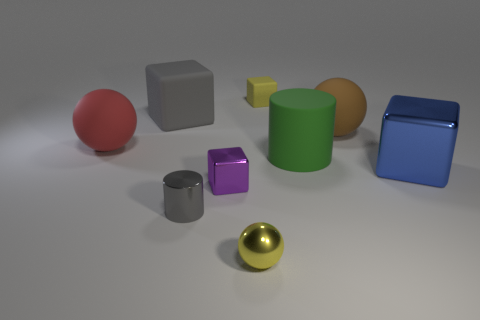Subtract all gray cubes. How many cubes are left? 3 Add 1 large objects. How many objects exist? 10 Subtract all yellow blocks. How many blocks are left? 3 Add 4 tiny matte blocks. How many tiny matte blocks are left? 5 Add 1 large brown rubber balls. How many large brown rubber balls exist? 2 Subtract 0 red cylinders. How many objects are left? 9 Subtract all cylinders. How many objects are left? 7 Subtract 1 spheres. How many spheres are left? 2 Subtract all purple spheres. Subtract all yellow blocks. How many spheres are left? 3 Subtract all tiny cyan blocks. Subtract all large blue metallic blocks. How many objects are left? 8 